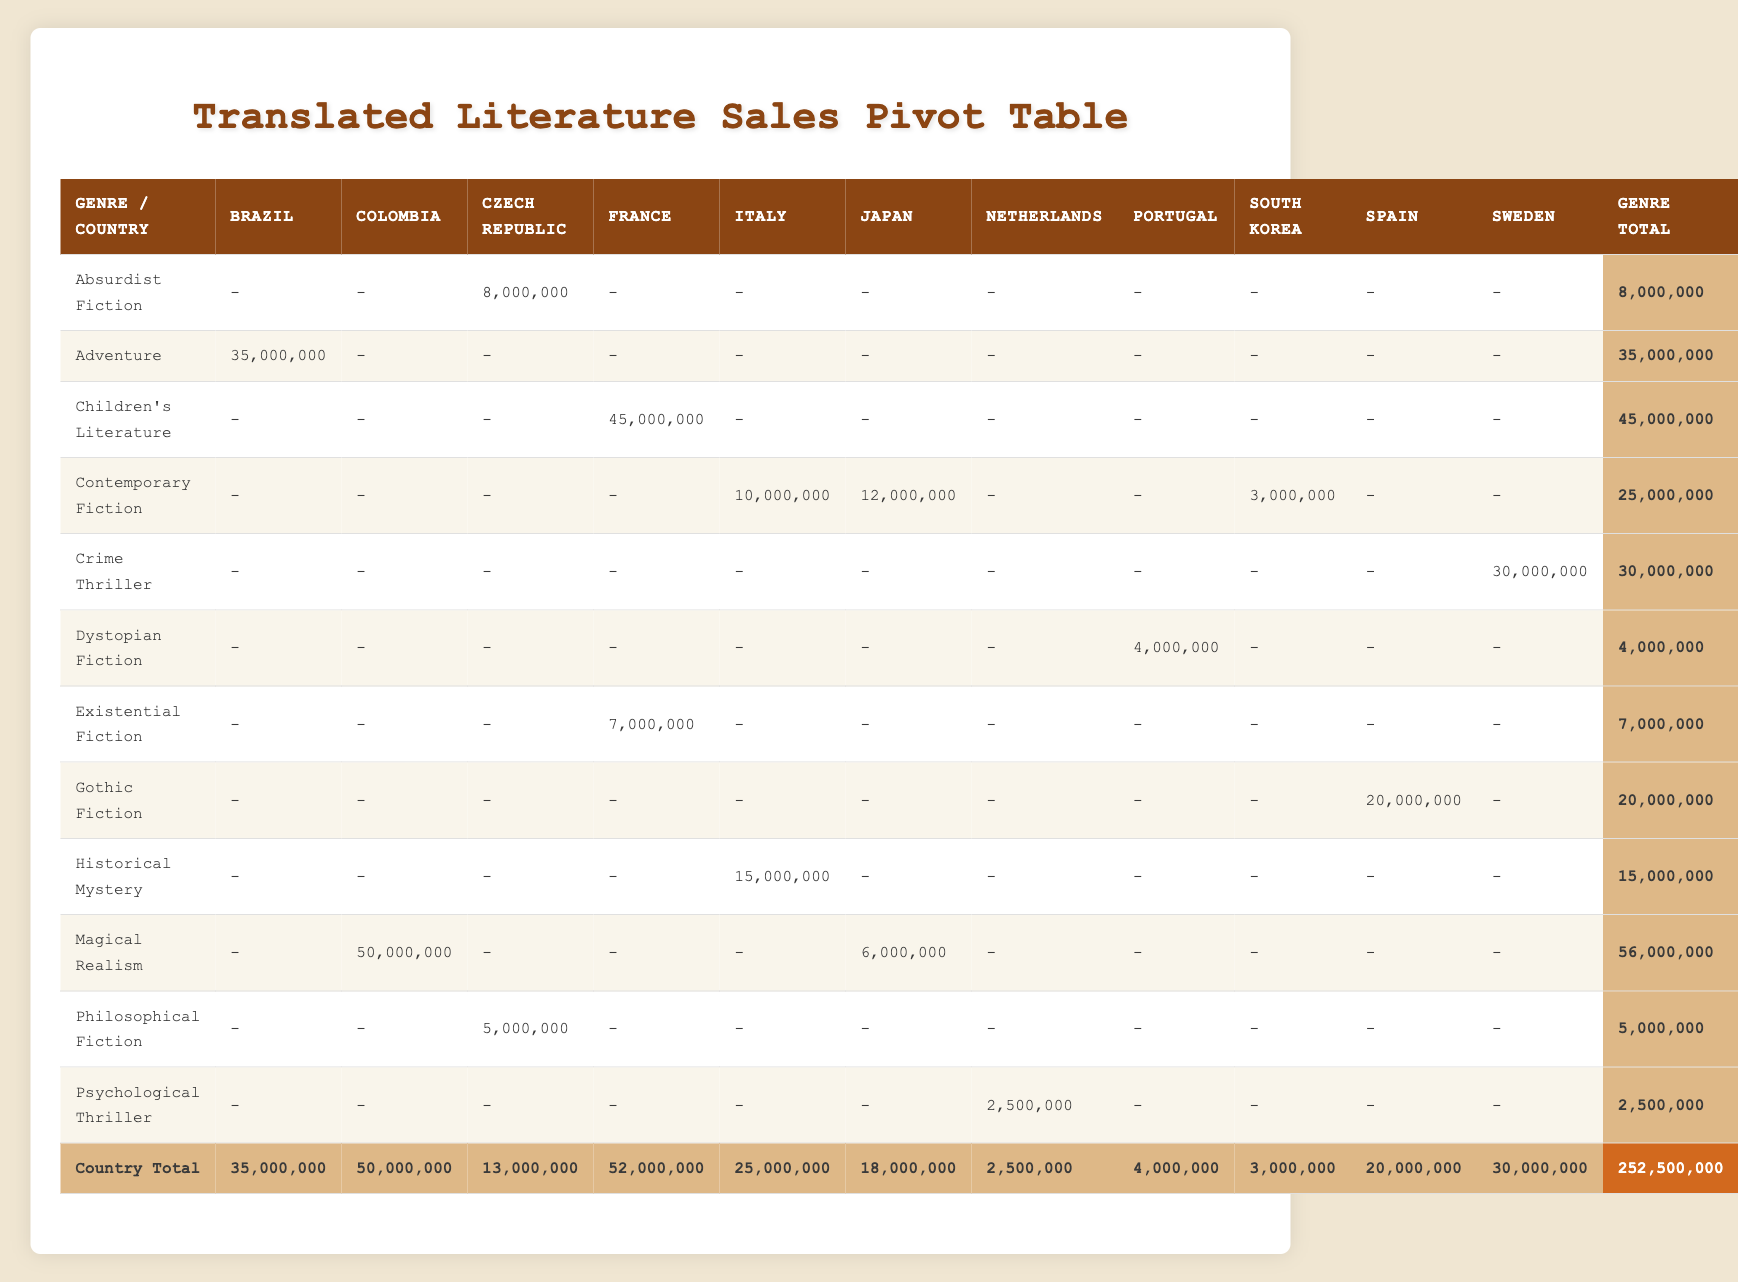What is the total sales for translated novels from Italy? To find the total sales for Italy, I look at the row for Italy in the sales data table. The sales for each genre from Italy listed are: Historical Mystery (15,000,000) and Contemporary Fiction (10,000,000). Adding these together gives 15,000,000 + 10,000,000 = 25,000,000.
Answer: 25,000,000 Which genre has the highest total sales overall? To determine which genre has the highest total sales, I need to check the Genre Total column. The totals for each genre are as follows: Absurdist Fiction (8,000,000), Adventure (35,000,000), Children's Literature (45,000,000), Contemporary Fiction (25,000,000), Crime Thriller (30,000,000), Dystopian Fiction (4,000,000), Existential Fiction (7,000,000), Gothic Fiction (20,000,000), Historical Mystery (15,000,000), Magical Realism (56,000,000), Philosophical Fiction (5,000,000), and Psychological Thriller (2,500,000). The highest total is 56,000,000 for Magical Realism.
Answer: Magical Realism Did South Korea have any novels that exceeded 3 million in sales? To answer this, I check the sales figure for South Korea in the table. The novel from South Korea, The Vegetarian, has sales of 3,000,000. Since this is not greater than 3 million, the answer is no.
Answer: No What is the combined sales of novels from Japan and France? First, I look at the sales figures for Japan and France. For Japan, the sales are 12,000,000 (Norwegian Wood) and 6,000,000 (The Wind-Up Bird Chronicle), which sum to 18,000,000. For France, the sales are 45,000,000 (The Little Prince) and 7,000,000 (The Stranger), which sum to 52,000,000. Now, I combine these two results: 18,000,000 + 52,000,000 = 70,000,000.
Answer: 70,000,000 Which genre contributes the most to total sales from Sweden? The only genre listed for Sweden is Crime Thriller, with sales of 30,000,000. Since this is the only entry, it automatically has the highest contribution from Sweden.
Answer: Crime Thriller What is the average sales figure for Contemporary Fiction? The sales for Contemporary Fiction from various countries are: 12,000,000 (Japan), 10,000,000 (Italy), and 3,000,000 (South Korea). To find the average, I first sum these values: 12,000,000 + 10,000,000 + 3,000,000 = 25,000,000. Then, since there are 3 data points, I divide the total by 3 to find the average: 25,000,000 / 3 = 8,333,333.33.
Answer: 8,333,333.33 